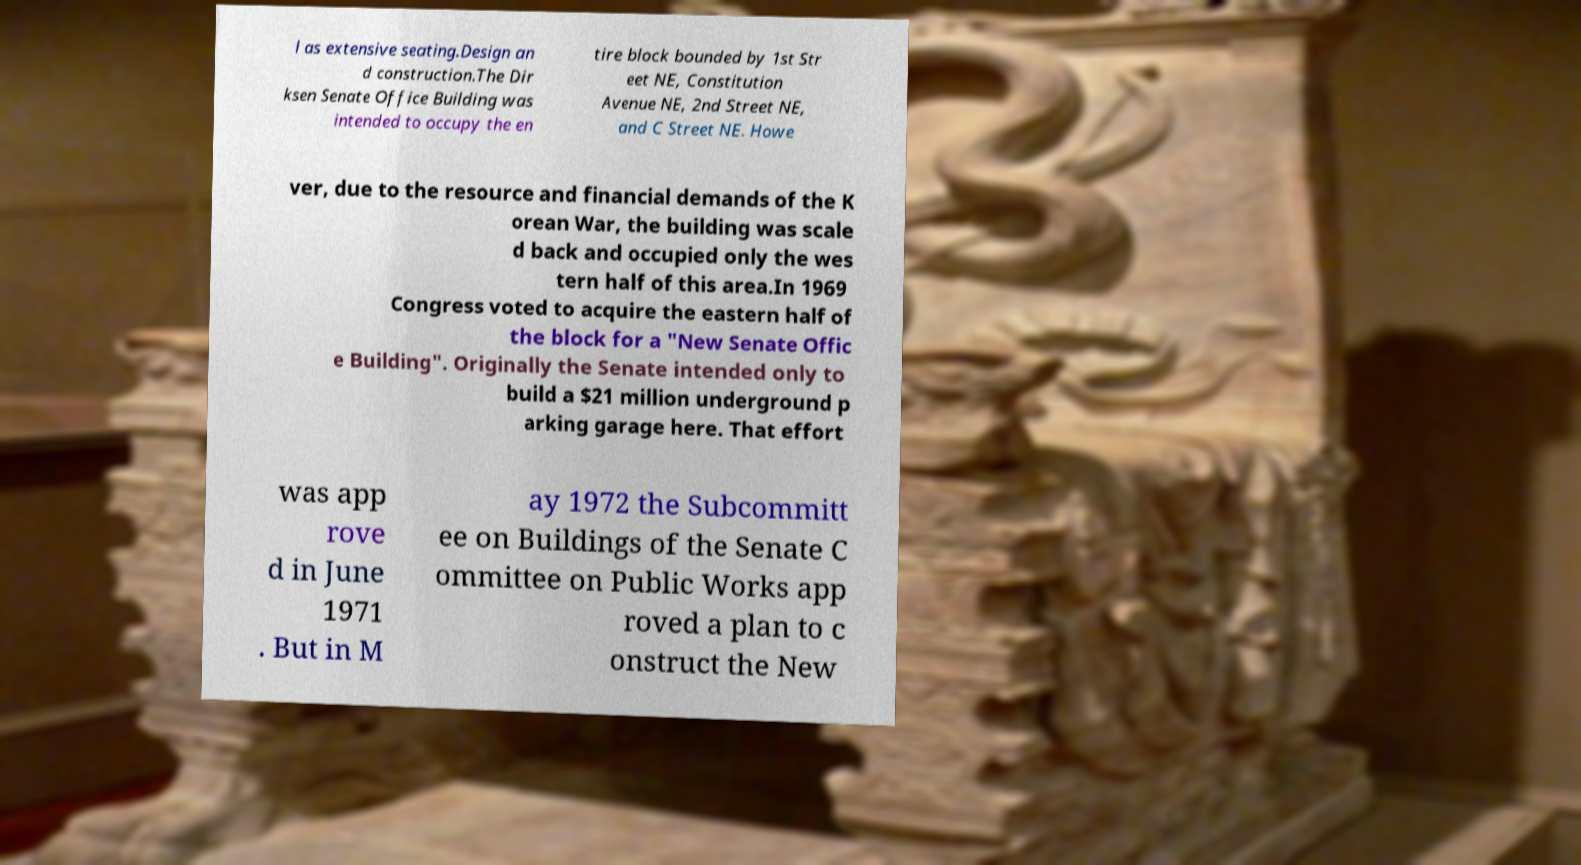For documentation purposes, I need the text within this image transcribed. Could you provide that? l as extensive seating.Design an d construction.The Dir ksen Senate Office Building was intended to occupy the en tire block bounded by 1st Str eet NE, Constitution Avenue NE, 2nd Street NE, and C Street NE. Howe ver, due to the resource and financial demands of the K orean War, the building was scale d back and occupied only the wes tern half of this area.In 1969 Congress voted to acquire the eastern half of the block for a "New Senate Offic e Building". Originally the Senate intended only to build a $21 million underground p arking garage here. That effort was app rove d in June 1971 . But in M ay 1972 the Subcommitt ee on Buildings of the Senate C ommittee on Public Works app roved a plan to c onstruct the New 